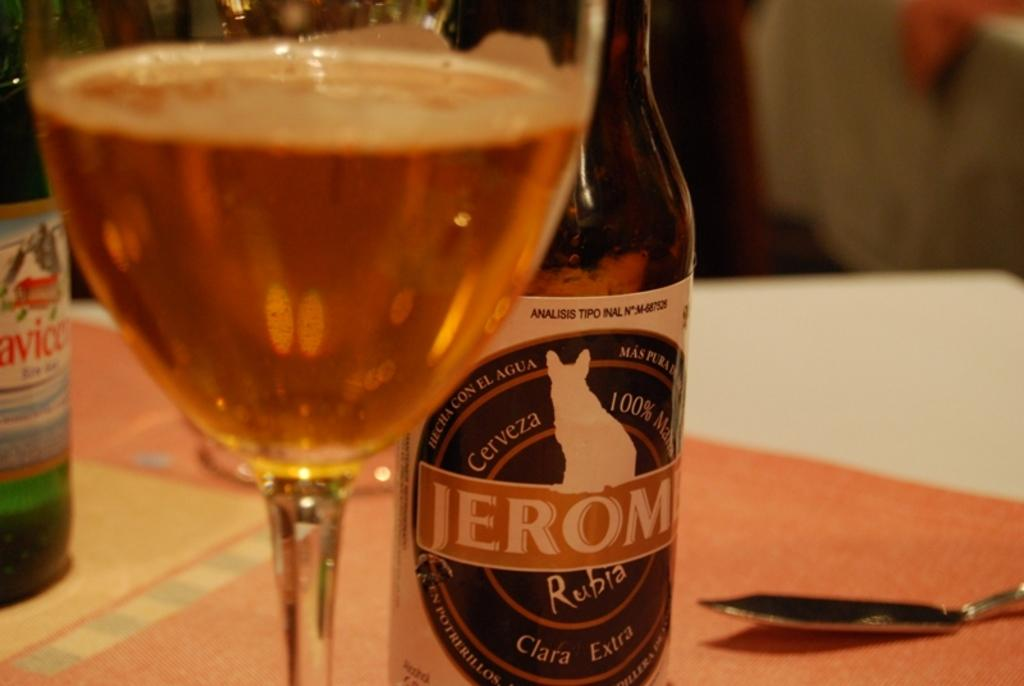Provide a one-sentence caption for the provided image. A glass filled with alcohol is on the table in front of two bottles and a spoon. 